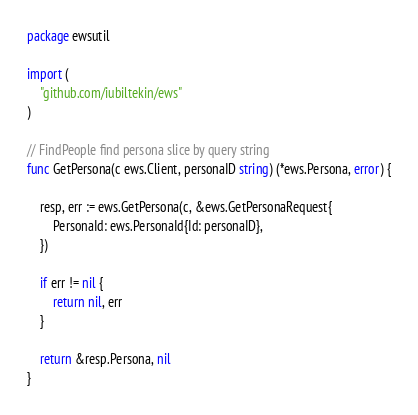<code> <loc_0><loc_0><loc_500><loc_500><_Go_>package ewsutil

import (
	"github.com/iubiltekin/ews"
)

// FindPeople find persona slice by query string
func GetPersona(c ews.Client, personaID string) (*ews.Persona, error) {

	resp, err := ews.GetPersona(c, &ews.GetPersonaRequest{
		PersonaId: ews.PersonaId{Id: personaID},
	})

	if err != nil {
		return nil, err
	}

	return &resp.Persona, nil
}
</code> 